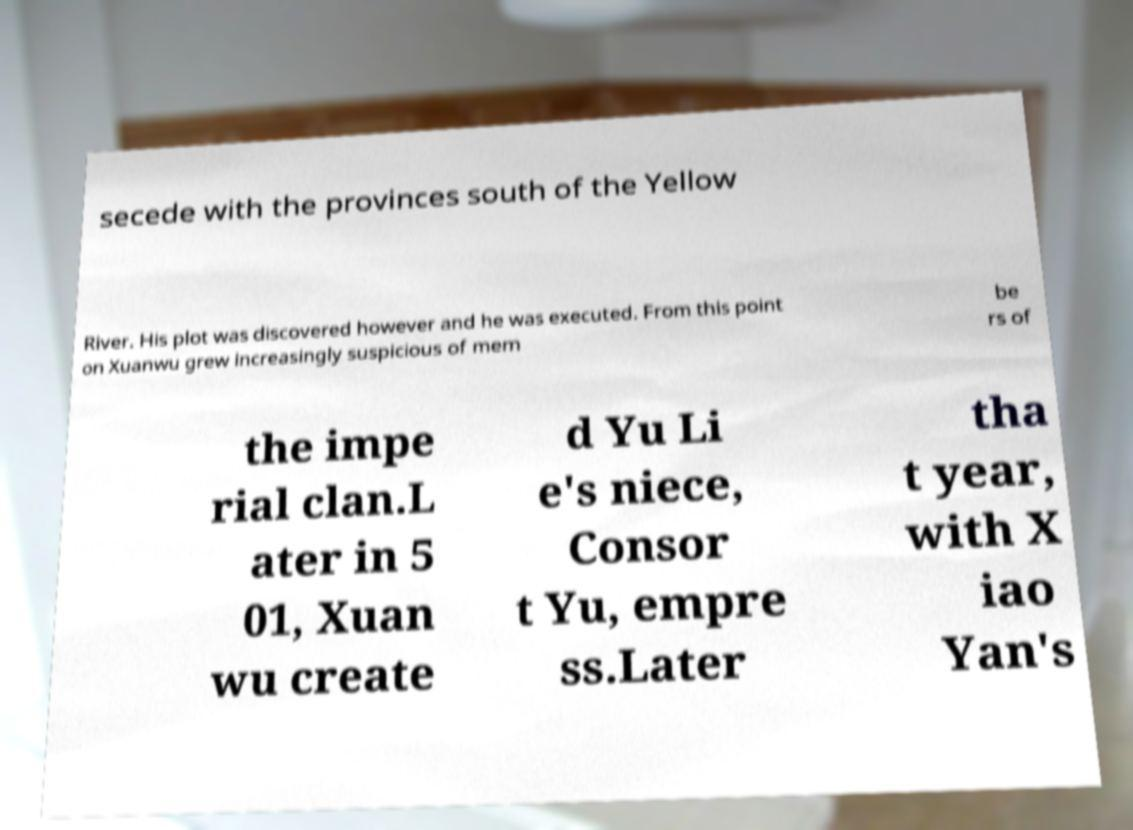Can you read and provide the text displayed in the image?This photo seems to have some interesting text. Can you extract and type it out for me? secede with the provinces south of the Yellow River. His plot was discovered however and he was executed. From this point on Xuanwu grew increasingly suspicious of mem be rs of the impe rial clan.L ater in 5 01, Xuan wu create d Yu Li e's niece, Consor t Yu, empre ss.Later tha t year, with X iao Yan's 